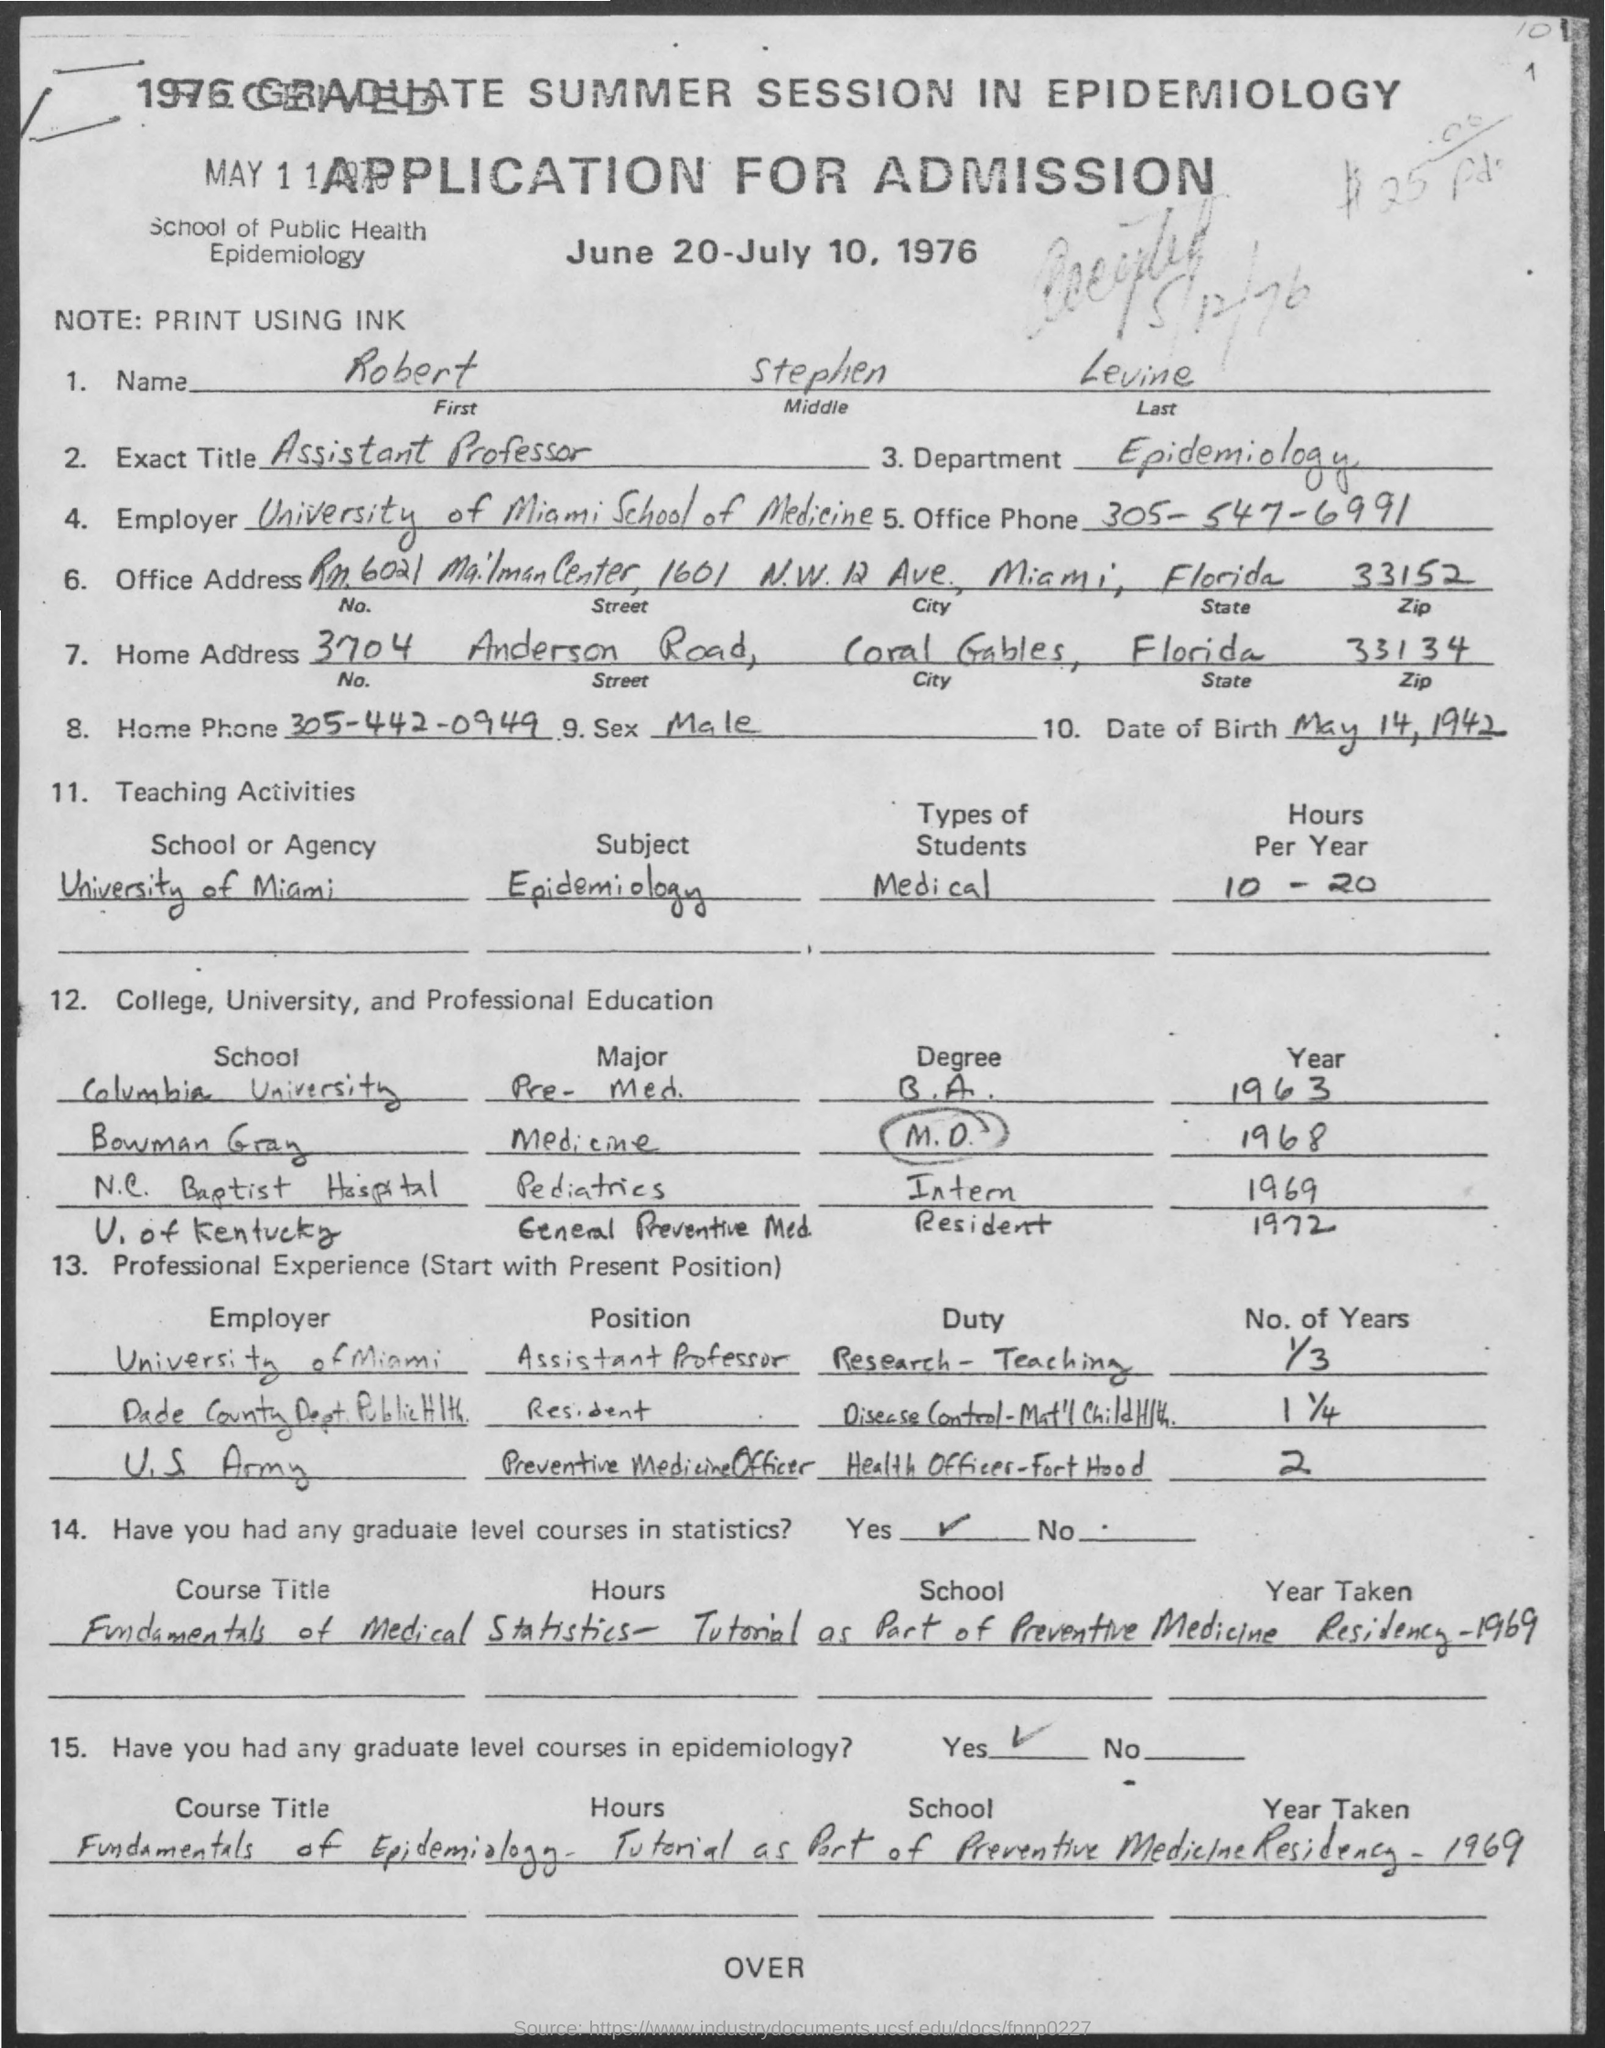What is the date of birth
Provide a succinct answer. May 14 , 1942. What is the name mentioned
Offer a terse response. Robert Stephen Levine. What is the office phone number
Offer a terse response. 305-547-6991. What is the home phone number ?
Your answer should be compact. 305-442-0949. Which street is mentioned in the home address
Your answer should be compact. Anderson Road. 